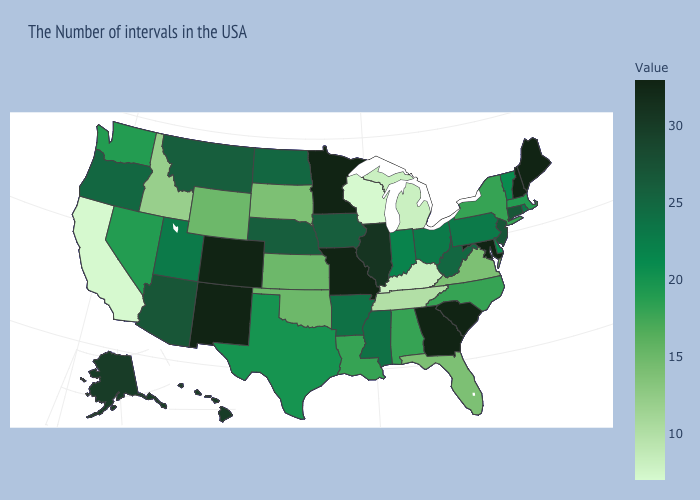Among the states that border Ohio , which have the lowest value?
Quick response, please. Michigan, Kentucky. Among the states that border Illinois , which have the lowest value?
Quick response, please. Wisconsin. Does California have a lower value than Delaware?
Concise answer only. Yes. Among the states that border Iowa , does Wisconsin have the lowest value?
Keep it brief. Yes. Is the legend a continuous bar?
Be succinct. Yes. 